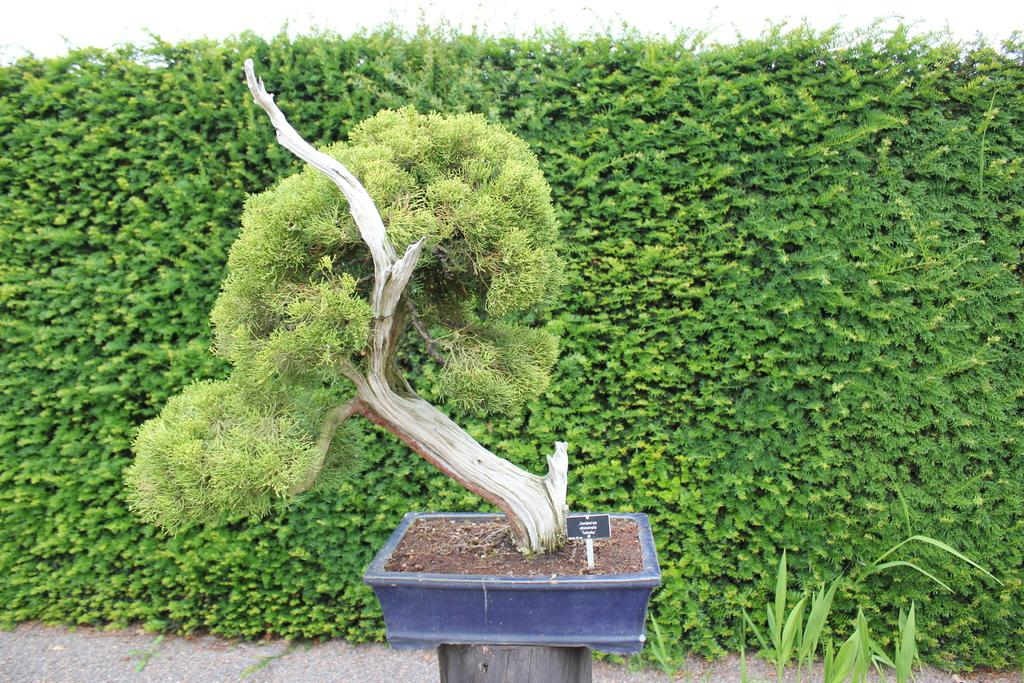What is located in the foreground of the image? There is a plant in the foreground of the image. What can be seen in the background of the image? There are bushes and a path visible in the background of the image. What is the color of the top part of the image? The top part of the image appears to be white in color. Can you see a girl holding a loaf of bread and a whip in the image? No, there is no girl, loaf of bread, or whip present in the image. 